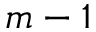<formula> <loc_0><loc_0><loc_500><loc_500>m - 1</formula> 